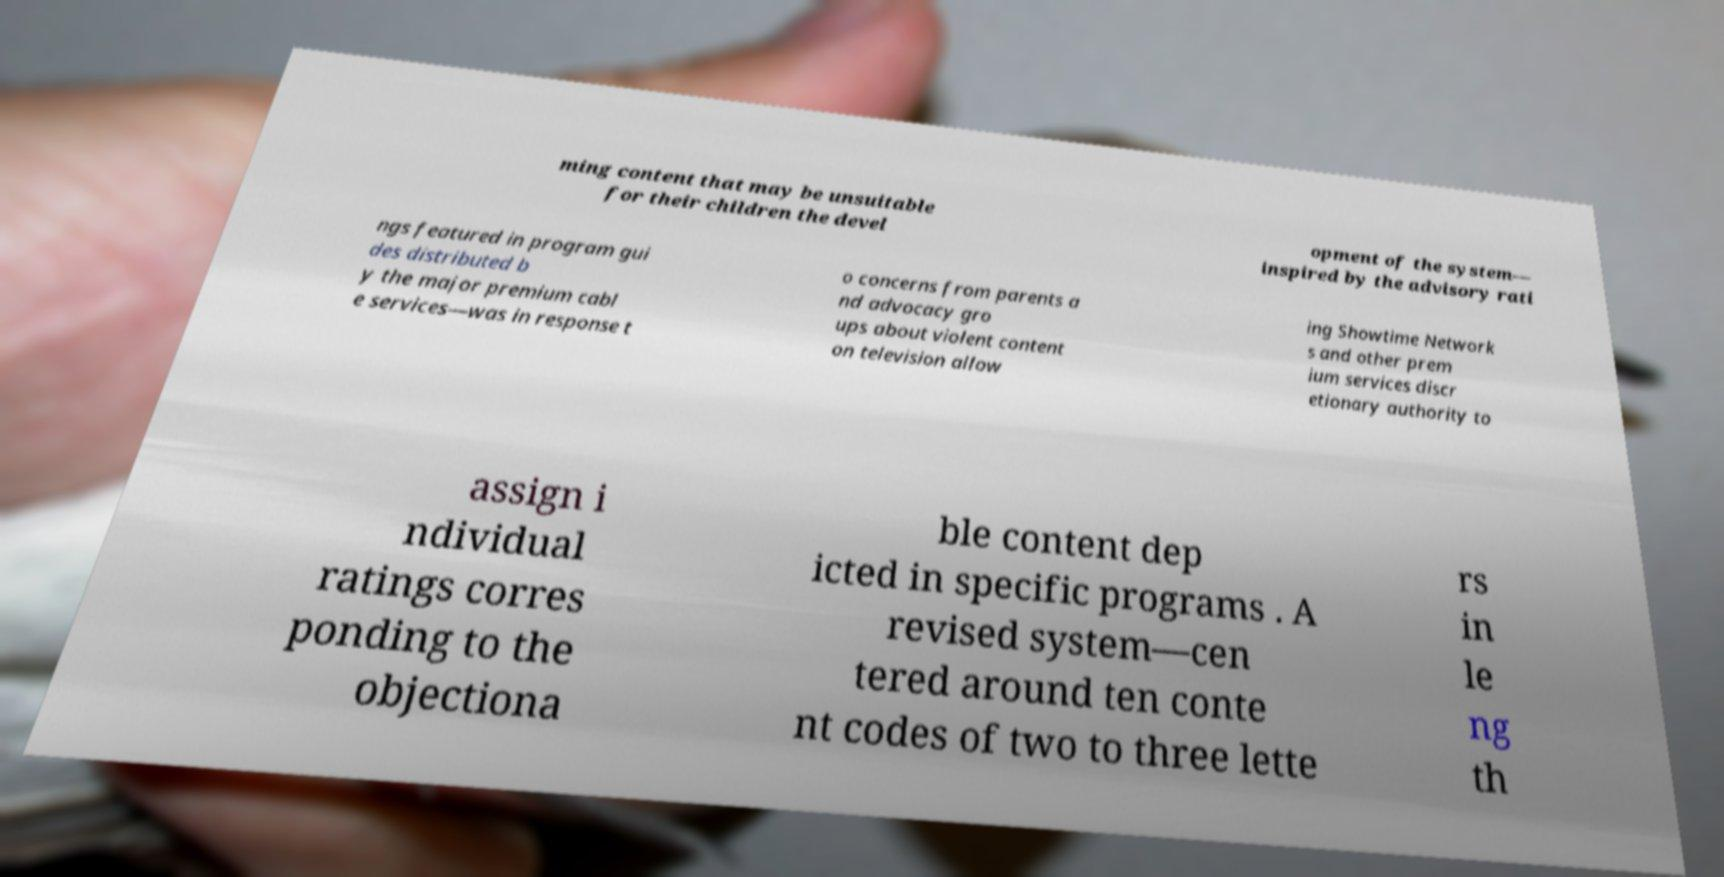Could you assist in decoding the text presented in this image and type it out clearly? ming content that may be unsuitable for their children the devel opment of the system— inspired by the advisory rati ngs featured in program gui des distributed b y the major premium cabl e services—was in response t o concerns from parents a nd advocacy gro ups about violent content on television allow ing Showtime Network s and other prem ium services discr etionary authority to assign i ndividual ratings corres ponding to the objectiona ble content dep icted in specific programs . A revised system—cen tered around ten conte nt codes of two to three lette rs in le ng th 